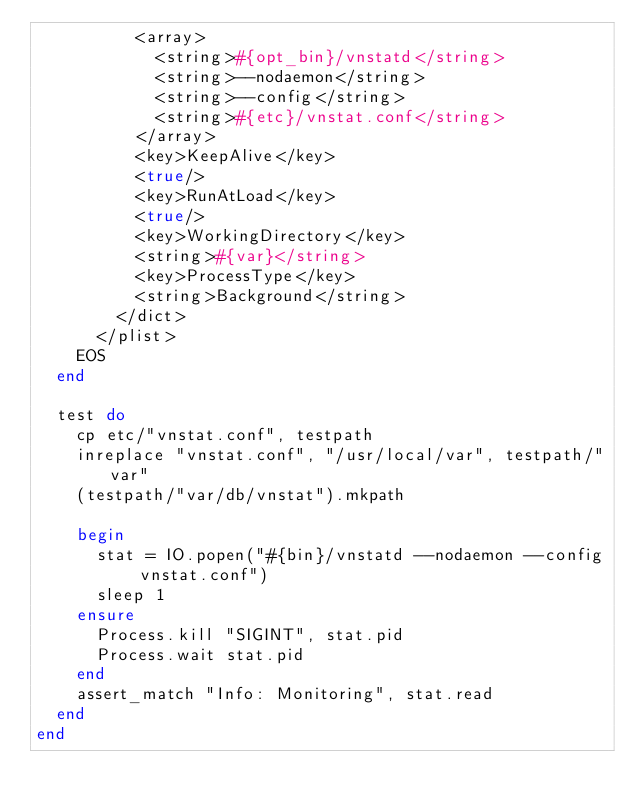<code> <loc_0><loc_0><loc_500><loc_500><_Ruby_>          <array>
            <string>#{opt_bin}/vnstatd</string>
            <string>--nodaemon</string>
            <string>--config</string>
            <string>#{etc}/vnstat.conf</string>
          </array>
          <key>KeepAlive</key>
          <true/>
          <key>RunAtLoad</key>
          <true/>
          <key>WorkingDirectory</key>
          <string>#{var}</string>
          <key>ProcessType</key>
          <string>Background</string>
        </dict>
      </plist>
    EOS
  end

  test do
    cp etc/"vnstat.conf", testpath
    inreplace "vnstat.conf", "/usr/local/var", testpath/"var"
    (testpath/"var/db/vnstat").mkpath

    begin
      stat = IO.popen("#{bin}/vnstatd --nodaemon --config vnstat.conf")
      sleep 1
    ensure
      Process.kill "SIGINT", stat.pid
      Process.wait stat.pid
    end
    assert_match "Info: Monitoring", stat.read
  end
end
</code> 